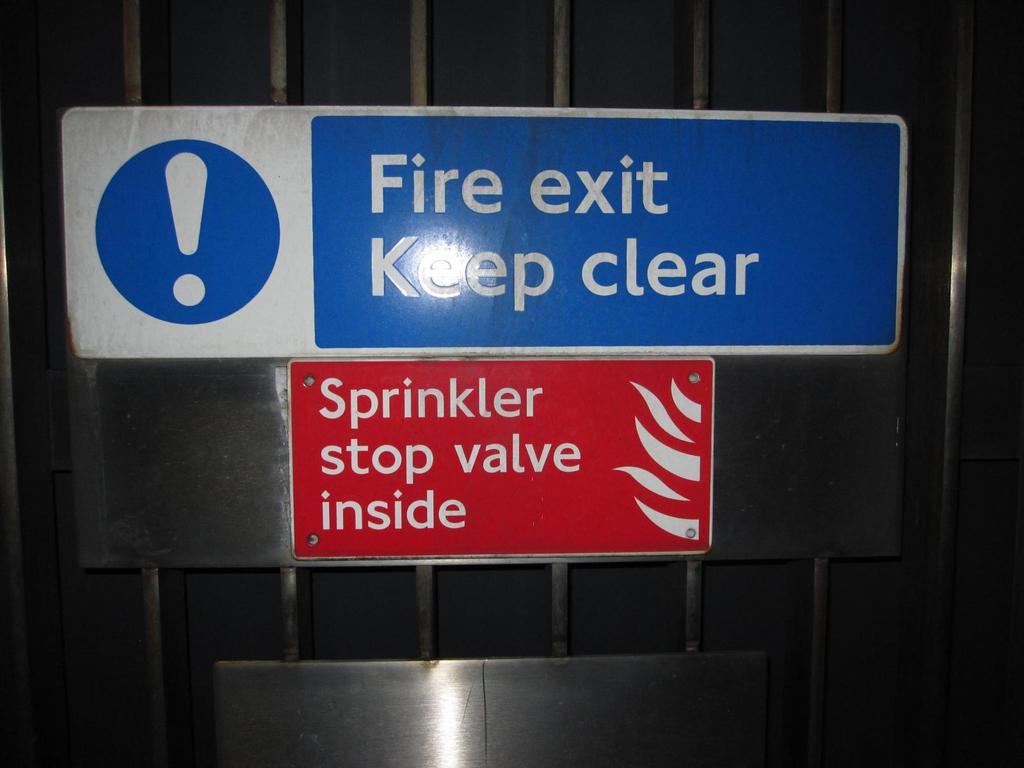What is inside?
Keep it short and to the point. Sprinkler stop valve. What type of exit is this?
Make the answer very short. Fire. 